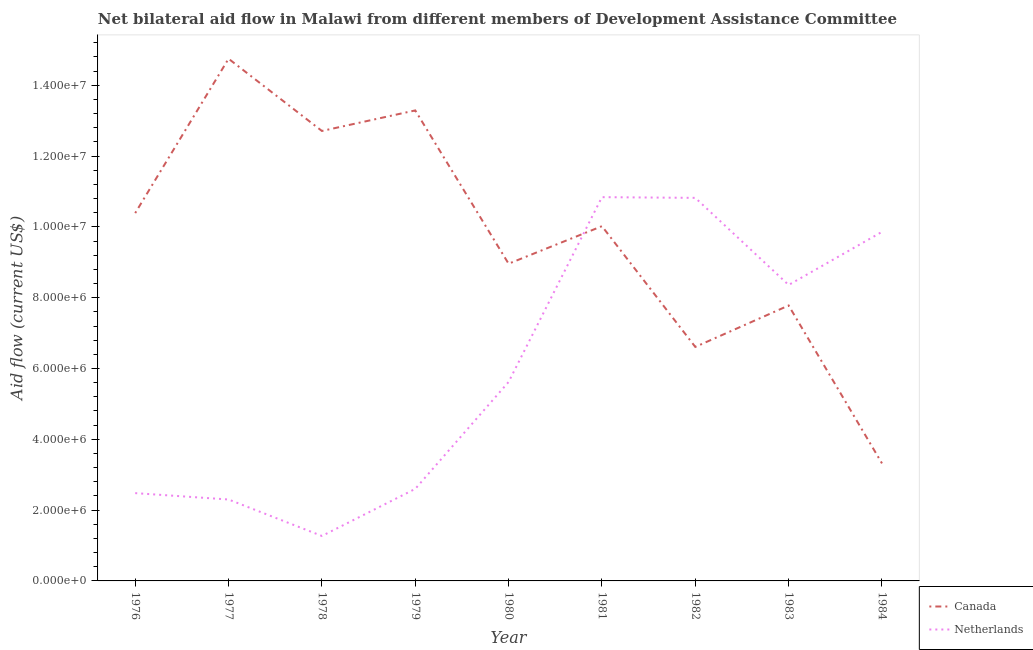How many different coloured lines are there?
Your response must be concise. 2. Does the line corresponding to amount of aid given by canada intersect with the line corresponding to amount of aid given by netherlands?
Provide a short and direct response. Yes. What is the amount of aid given by canada in 1981?
Offer a very short reply. 1.00e+07. Across all years, what is the maximum amount of aid given by netherlands?
Provide a succinct answer. 1.08e+07. Across all years, what is the minimum amount of aid given by canada?
Give a very brief answer. 3.32e+06. In which year was the amount of aid given by canada maximum?
Make the answer very short. 1977. In which year was the amount of aid given by canada minimum?
Your answer should be very brief. 1984. What is the total amount of aid given by canada in the graph?
Keep it short and to the point. 8.78e+07. What is the difference between the amount of aid given by canada in 1977 and that in 1978?
Make the answer very short. 2.04e+06. What is the difference between the amount of aid given by canada in 1977 and the amount of aid given by netherlands in 1982?
Your answer should be compact. 3.93e+06. What is the average amount of aid given by netherlands per year?
Make the answer very short. 6.02e+06. In the year 1976, what is the difference between the amount of aid given by netherlands and amount of aid given by canada?
Provide a succinct answer. -7.91e+06. In how many years, is the amount of aid given by netherlands greater than 6800000 US$?
Provide a short and direct response. 4. What is the ratio of the amount of aid given by netherlands in 1977 to that in 1979?
Your response must be concise. 0.88. Is the amount of aid given by canada in 1977 less than that in 1982?
Ensure brevity in your answer.  No. Is the difference between the amount of aid given by netherlands in 1976 and 1981 greater than the difference between the amount of aid given by canada in 1976 and 1981?
Keep it short and to the point. No. What is the difference between the highest and the second highest amount of aid given by canada?
Your answer should be very brief. 1.46e+06. What is the difference between the highest and the lowest amount of aid given by canada?
Provide a succinct answer. 1.14e+07. Is the amount of aid given by netherlands strictly greater than the amount of aid given by canada over the years?
Your answer should be very brief. No. Is the amount of aid given by netherlands strictly less than the amount of aid given by canada over the years?
Your response must be concise. No. What is the difference between two consecutive major ticks on the Y-axis?
Your response must be concise. 2.00e+06. Are the values on the major ticks of Y-axis written in scientific E-notation?
Ensure brevity in your answer.  Yes. Does the graph contain grids?
Make the answer very short. No. How many legend labels are there?
Ensure brevity in your answer.  2. How are the legend labels stacked?
Your answer should be compact. Vertical. What is the title of the graph?
Offer a very short reply. Net bilateral aid flow in Malawi from different members of Development Assistance Committee. What is the Aid flow (current US$) in Canada in 1976?
Provide a succinct answer. 1.04e+07. What is the Aid flow (current US$) of Netherlands in 1976?
Your answer should be compact. 2.48e+06. What is the Aid flow (current US$) in Canada in 1977?
Ensure brevity in your answer.  1.48e+07. What is the Aid flow (current US$) in Netherlands in 1977?
Offer a terse response. 2.30e+06. What is the Aid flow (current US$) in Canada in 1978?
Offer a terse response. 1.27e+07. What is the Aid flow (current US$) in Netherlands in 1978?
Your answer should be very brief. 1.27e+06. What is the Aid flow (current US$) in Canada in 1979?
Provide a succinct answer. 1.33e+07. What is the Aid flow (current US$) in Netherlands in 1979?
Your answer should be very brief. 2.60e+06. What is the Aid flow (current US$) in Canada in 1980?
Your response must be concise. 8.96e+06. What is the Aid flow (current US$) in Netherlands in 1980?
Ensure brevity in your answer.  5.62e+06. What is the Aid flow (current US$) in Canada in 1981?
Give a very brief answer. 1.00e+07. What is the Aid flow (current US$) in Netherlands in 1981?
Your response must be concise. 1.08e+07. What is the Aid flow (current US$) in Canada in 1982?
Give a very brief answer. 6.61e+06. What is the Aid flow (current US$) in Netherlands in 1982?
Offer a terse response. 1.08e+07. What is the Aid flow (current US$) in Canada in 1983?
Ensure brevity in your answer.  7.78e+06. What is the Aid flow (current US$) in Netherlands in 1983?
Keep it short and to the point. 8.36e+06. What is the Aid flow (current US$) in Canada in 1984?
Offer a very short reply. 3.32e+06. What is the Aid flow (current US$) in Netherlands in 1984?
Keep it short and to the point. 9.86e+06. Across all years, what is the maximum Aid flow (current US$) in Canada?
Your response must be concise. 1.48e+07. Across all years, what is the maximum Aid flow (current US$) of Netherlands?
Offer a very short reply. 1.08e+07. Across all years, what is the minimum Aid flow (current US$) of Canada?
Your answer should be compact. 3.32e+06. Across all years, what is the minimum Aid flow (current US$) in Netherlands?
Make the answer very short. 1.27e+06. What is the total Aid flow (current US$) of Canada in the graph?
Provide a short and direct response. 8.78e+07. What is the total Aid flow (current US$) of Netherlands in the graph?
Provide a succinct answer. 5.42e+07. What is the difference between the Aid flow (current US$) of Canada in 1976 and that in 1977?
Make the answer very short. -4.36e+06. What is the difference between the Aid flow (current US$) of Canada in 1976 and that in 1978?
Your answer should be compact. -2.32e+06. What is the difference between the Aid flow (current US$) in Netherlands in 1976 and that in 1978?
Your response must be concise. 1.21e+06. What is the difference between the Aid flow (current US$) in Canada in 1976 and that in 1979?
Keep it short and to the point. -2.90e+06. What is the difference between the Aid flow (current US$) in Netherlands in 1976 and that in 1979?
Your answer should be very brief. -1.20e+05. What is the difference between the Aid flow (current US$) of Canada in 1976 and that in 1980?
Keep it short and to the point. 1.43e+06. What is the difference between the Aid flow (current US$) in Netherlands in 1976 and that in 1980?
Give a very brief answer. -3.14e+06. What is the difference between the Aid flow (current US$) in Canada in 1976 and that in 1981?
Give a very brief answer. 3.70e+05. What is the difference between the Aid flow (current US$) in Netherlands in 1976 and that in 1981?
Provide a short and direct response. -8.36e+06. What is the difference between the Aid flow (current US$) of Canada in 1976 and that in 1982?
Ensure brevity in your answer.  3.78e+06. What is the difference between the Aid flow (current US$) in Netherlands in 1976 and that in 1982?
Your response must be concise. -8.34e+06. What is the difference between the Aid flow (current US$) in Canada in 1976 and that in 1983?
Offer a very short reply. 2.61e+06. What is the difference between the Aid flow (current US$) of Netherlands in 1976 and that in 1983?
Your response must be concise. -5.88e+06. What is the difference between the Aid flow (current US$) of Canada in 1976 and that in 1984?
Your answer should be very brief. 7.07e+06. What is the difference between the Aid flow (current US$) in Netherlands in 1976 and that in 1984?
Keep it short and to the point. -7.38e+06. What is the difference between the Aid flow (current US$) in Canada in 1977 and that in 1978?
Ensure brevity in your answer.  2.04e+06. What is the difference between the Aid flow (current US$) of Netherlands in 1977 and that in 1978?
Provide a short and direct response. 1.03e+06. What is the difference between the Aid flow (current US$) of Canada in 1977 and that in 1979?
Ensure brevity in your answer.  1.46e+06. What is the difference between the Aid flow (current US$) of Netherlands in 1977 and that in 1979?
Give a very brief answer. -3.00e+05. What is the difference between the Aid flow (current US$) in Canada in 1977 and that in 1980?
Make the answer very short. 5.79e+06. What is the difference between the Aid flow (current US$) in Netherlands in 1977 and that in 1980?
Provide a succinct answer. -3.32e+06. What is the difference between the Aid flow (current US$) in Canada in 1977 and that in 1981?
Give a very brief answer. 4.73e+06. What is the difference between the Aid flow (current US$) of Netherlands in 1977 and that in 1981?
Give a very brief answer. -8.54e+06. What is the difference between the Aid flow (current US$) of Canada in 1977 and that in 1982?
Your answer should be very brief. 8.14e+06. What is the difference between the Aid flow (current US$) in Netherlands in 1977 and that in 1982?
Keep it short and to the point. -8.52e+06. What is the difference between the Aid flow (current US$) in Canada in 1977 and that in 1983?
Provide a succinct answer. 6.97e+06. What is the difference between the Aid flow (current US$) of Netherlands in 1977 and that in 1983?
Your answer should be compact. -6.06e+06. What is the difference between the Aid flow (current US$) of Canada in 1977 and that in 1984?
Ensure brevity in your answer.  1.14e+07. What is the difference between the Aid flow (current US$) in Netherlands in 1977 and that in 1984?
Make the answer very short. -7.56e+06. What is the difference between the Aid flow (current US$) in Canada in 1978 and that in 1979?
Offer a terse response. -5.80e+05. What is the difference between the Aid flow (current US$) of Netherlands in 1978 and that in 1979?
Provide a succinct answer. -1.33e+06. What is the difference between the Aid flow (current US$) of Canada in 1978 and that in 1980?
Offer a terse response. 3.75e+06. What is the difference between the Aid flow (current US$) of Netherlands in 1978 and that in 1980?
Your answer should be very brief. -4.35e+06. What is the difference between the Aid flow (current US$) of Canada in 1978 and that in 1981?
Your answer should be very brief. 2.69e+06. What is the difference between the Aid flow (current US$) of Netherlands in 1978 and that in 1981?
Your response must be concise. -9.57e+06. What is the difference between the Aid flow (current US$) in Canada in 1978 and that in 1982?
Ensure brevity in your answer.  6.10e+06. What is the difference between the Aid flow (current US$) of Netherlands in 1978 and that in 1982?
Keep it short and to the point. -9.55e+06. What is the difference between the Aid flow (current US$) of Canada in 1978 and that in 1983?
Give a very brief answer. 4.93e+06. What is the difference between the Aid flow (current US$) in Netherlands in 1978 and that in 1983?
Provide a succinct answer. -7.09e+06. What is the difference between the Aid flow (current US$) of Canada in 1978 and that in 1984?
Your answer should be compact. 9.39e+06. What is the difference between the Aid flow (current US$) in Netherlands in 1978 and that in 1984?
Your response must be concise. -8.59e+06. What is the difference between the Aid flow (current US$) in Canada in 1979 and that in 1980?
Ensure brevity in your answer.  4.33e+06. What is the difference between the Aid flow (current US$) in Netherlands in 1979 and that in 1980?
Provide a succinct answer. -3.02e+06. What is the difference between the Aid flow (current US$) in Canada in 1979 and that in 1981?
Your answer should be very brief. 3.27e+06. What is the difference between the Aid flow (current US$) of Netherlands in 1979 and that in 1981?
Provide a short and direct response. -8.24e+06. What is the difference between the Aid flow (current US$) in Canada in 1979 and that in 1982?
Make the answer very short. 6.68e+06. What is the difference between the Aid flow (current US$) in Netherlands in 1979 and that in 1982?
Make the answer very short. -8.22e+06. What is the difference between the Aid flow (current US$) in Canada in 1979 and that in 1983?
Offer a very short reply. 5.51e+06. What is the difference between the Aid flow (current US$) of Netherlands in 1979 and that in 1983?
Offer a very short reply. -5.76e+06. What is the difference between the Aid flow (current US$) in Canada in 1979 and that in 1984?
Offer a terse response. 9.97e+06. What is the difference between the Aid flow (current US$) of Netherlands in 1979 and that in 1984?
Provide a succinct answer. -7.26e+06. What is the difference between the Aid flow (current US$) in Canada in 1980 and that in 1981?
Keep it short and to the point. -1.06e+06. What is the difference between the Aid flow (current US$) of Netherlands in 1980 and that in 1981?
Keep it short and to the point. -5.22e+06. What is the difference between the Aid flow (current US$) of Canada in 1980 and that in 1982?
Your answer should be compact. 2.35e+06. What is the difference between the Aid flow (current US$) in Netherlands in 1980 and that in 1982?
Your answer should be compact. -5.20e+06. What is the difference between the Aid flow (current US$) of Canada in 1980 and that in 1983?
Make the answer very short. 1.18e+06. What is the difference between the Aid flow (current US$) in Netherlands in 1980 and that in 1983?
Your response must be concise. -2.74e+06. What is the difference between the Aid flow (current US$) in Canada in 1980 and that in 1984?
Make the answer very short. 5.64e+06. What is the difference between the Aid flow (current US$) in Netherlands in 1980 and that in 1984?
Give a very brief answer. -4.24e+06. What is the difference between the Aid flow (current US$) of Canada in 1981 and that in 1982?
Ensure brevity in your answer.  3.41e+06. What is the difference between the Aid flow (current US$) of Canada in 1981 and that in 1983?
Provide a succinct answer. 2.24e+06. What is the difference between the Aid flow (current US$) of Netherlands in 1981 and that in 1983?
Give a very brief answer. 2.48e+06. What is the difference between the Aid flow (current US$) in Canada in 1981 and that in 1984?
Keep it short and to the point. 6.70e+06. What is the difference between the Aid flow (current US$) in Netherlands in 1981 and that in 1984?
Give a very brief answer. 9.80e+05. What is the difference between the Aid flow (current US$) of Canada in 1982 and that in 1983?
Your answer should be compact. -1.17e+06. What is the difference between the Aid flow (current US$) of Netherlands in 1982 and that in 1983?
Give a very brief answer. 2.46e+06. What is the difference between the Aid flow (current US$) of Canada in 1982 and that in 1984?
Give a very brief answer. 3.29e+06. What is the difference between the Aid flow (current US$) in Netherlands in 1982 and that in 1984?
Provide a short and direct response. 9.60e+05. What is the difference between the Aid flow (current US$) in Canada in 1983 and that in 1984?
Your answer should be very brief. 4.46e+06. What is the difference between the Aid flow (current US$) of Netherlands in 1983 and that in 1984?
Provide a succinct answer. -1.50e+06. What is the difference between the Aid flow (current US$) of Canada in 1976 and the Aid flow (current US$) of Netherlands in 1977?
Offer a very short reply. 8.09e+06. What is the difference between the Aid flow (current US$) of Canada in 1976 and the Aid flow (current US$) of Netherlands in 1978?
Offer a very short reply. 9.12e+06. What is the difference between the Aid flow (current US$) of Canada in 1976 and the Aid flow (current US$) of Netherlands in 1979?
Provide a succinct answer. 7.79e+06. What is the difference between the Aid flow (current US$) of Canada in 1976 and the Aid flow (current US$) of Netherlands in 1980?
Your response must be concise. 4.77e+06. What is the difference between the Aid flow (current US$) in Canada in 1976 and the Aid flow (current US$) in Netherlands in 1981?
Offer a terse response. -4.50e+05. What is the difference between the Aid flow (current US$) of Canada in 1976 and the Aid flow (current US$) of Netherlands in 1982?
Ensure brevity in your answer.  -4.30e+05. What is the difference between the Aid flow (current US$) in Canada in 1976 and the Aid flow (current US$) in Netherlands in 1983?
Provide a succinct answer. 2.03e+06. What is the difference between the Aid flow (current US$) in Canada in 1976 and the Aid flow (current US$) in Netherlands in 1984?
Provide a succinct answer. 5.30e+05. What is the difference between the Aid flow (current US$) of Canada in 1977 and the Aid flow (current US$) of Netherlands in 1978?
Offer a terse response. 1.35e+07. What is the difference between the Aid flow (current US$) of Canada in 1977 and the Aid flow (current US$) of Netherlands in 1979?
Keep it short and to the point. 1.22e+07. What is the difference between the Aid flow (current US$) of Canada in 1977 and the Aid flow (current US$) of Netherlands in 1980?
Your answer should be compact. 9.13e+06. What is the difference between the Aid flow (current US$) in Canada in 1977 and the Aid flow (current US$) in Netherlands in 1981?
Your response must be concise. 3.91e+06. What is the difference between the Aid flow (current US$) in Canada in 1977 and the Aid flow (current US$) in Netherlands in 1982?
Offer a terse response. 3.93e+06. What is the difference between the Aid flow (current US$) of Canada in 1977 and the Aid flow (current US$) of Netherlands in 1983?
Keep it short and to the point. 6.39e+06. What is the difference between the Aid flow (current US$) of Canada in 1977 and the Aid flow (current US$) of Netherlands in 1984?
Keep it short and to the point. 4.89e+06. What is the difference between the Aid flow (current US$) in Canada in 1978 and the Aid flow (current US$) in Netherlands in 1979?
Provide a short and direct response. 1.01e+07. What is the difference between the Aid flow (current US$) in Canada in 1978 and the Aid flow (current US$) in Netherlands in 1980?
Ensure brevity in your answer.  7.09e+06. What is the difference between the Aid flow (current US$) in Canada in 1978 and the Aid flow (current US$) in Netherlands in 1981?
Give a very brief answer. 1.87e+06. What is the difference between the Aid flow (current US$) in Canada in 1978 and the Aid flow (current US$) in Netherlands in 1982?
Your response must be concise. 1.89e+06. What is the difference between the Aid flow (current US$) of Canada in 1978 and the Aid flow (current US$) of Netherlands in 1983?
Your answer should be very brief. 4.35e+06. What is the difference between the Aid flow (current US$) of Canada in 1978 and the Aid flow (current US$) of Netherlands in 1984?
Make the answer very short. 2.85e+06. What is the difference between the Aid flow (current US$) in Canada in 1979 and the Aid flow (current US$) in Netherlands in 1980?
Your answer should be compact. 7.67e+06. What is the difference between the Aid flow (current US$) of Canada in 1979 and the Aid flow (current US$) of Netherlands in 1981?
Make the answer very short. 2.45e+06. What is the difference between the Aid flow (current US$) of Canada in 1979 and the Aid flow (current US$) of Netherlands in 1982?
Ensure brevity in your answer.  2.47e+06. What is the difference between the Aid flow (current US$) of Canada in 1979 and the Aid flow (current US$) of Netherlands in 1983?
Provide a succinct answer. 4.93e+06. What is the difference between the Aid flow (current US$) of Canada in 1979 and the Aid flow (current US$) of Netherlands in 1984?
Offer a very short reply. 3.43e+06. What is the difference between the Aid flow (current US$) of Canada in 1980 and the Aid flow (current US$) of Netherlands in 1981?
Make the answer very short. -1.88e+06. What is the difference between the Aid flow (current US$) in Canada in 1980 and the Aid flow (current US$) in Netherlands in 1982?
Provide a short and direct response. -1.86e+06. What is the difference between the Aid flow (current US$) of Canada in 1980 and the Aid flow (current US$) of Netherlands in 1983?
Keep it short and to the point. 6.00e+05. What is the difference between the Aid flow (current US$) in Canada in 1980 and the Aid flow (current US$) in Netherlands in 1984?
Offer a terse response. -9.00e+05. What is the difference between the Aid flow (current US$) in Canada in 1981 and the Aid flow (current US$) in Netherlands in 1982?
Offer a very short reply. -8.00e+05. What is the difference between the Aid flow (current US$) of Canada in 1981 and the Aid flow (current US$) of Netherlands in 1983?
Give a very brief answer. 1.66e+06. What is the difference between the Aid flow (current US$) of Canada in 1981 and the Aid flow (current US$) of Netherlands in 1984?
Offer a terse response. 1.60e+05. What is the difference between the Aid flow (current US$) of Canada in 1982 and the Aid flow (current US$) of Netherlands in 1983?
Make the answer very short. -1.75e+06. What is the difference between the Aid flow (current US$) in Canada in 1982 and the Aid flow (current US$) in Netherlands in 1984?
Give a very brief answer. -3.25e+06. What is the difference between the Aid flow (current US$) in Canada in 1983 and the Aid flow (current US$) in Netherlands in 1984?
Provide a succinct answer. -2.08e+06. What is the average Aid flow (current US$) of Canada per year?
Your answer should be compact. 9.76e+06. What is the average Aid flow (current US$) of Netherlands per year?
Make the answer very short. 6.02e+06. In the year 1976, what is the difference between the Aid flow (current US$) in Canada and Aid flow (current US$) in Netherlands?
Keep it short and to the point. 7.91e+06. In the year 1977, what is the difference between the Aid flow (current US$) in Canada and Aid flow (current US$) in Netherlands?
Your answer should be compact. 1.24e+07. In the year 1978, what is the difference between the Aid flow (current US$) in Canada and Aid flow (current US$) in Netherlands?
Your answer should be very brief. 1.14e+07. In the year 1979, what is the difference between the Aid flow (current US$) in Canada and Aid flow (current US$) in Netherlands?
Provide a succinct answer. 1.07e+07. In the year 1980, what is the difference between the Aid flow (current US$) of Canada and Aid flow (current US$) of Netherlands?
Provide a succinct answer. 3.34e+06. In the year 1981, what is the difference between the Aid flow (current US$) of Canada and Aid flow (current US$) of Netherlands?
Give a very brief answer. -8.20e+05. In the year 1982, what is the difference between the Aid flow (current US$) of Canada and Aid flow (current US$) of Netherlands?
Offer a very short reply. -4.21e+06. In the year 1983, what is the difference between the Aid flow (current US$) of Canada and Aid flow (current US$) of Netherlands?
Give a very brief answer. -5.80e+05. In the year 1984, what is the difference between the Aid flow (current US$) of Canada and Aid flow (current US$) of Netherlands?
Offer a terse response. -6.54e+06. What is the ratio of the Aid flow (current US$) of Canada in 1976 to that in 1977?
Provide a succinct answer. 0.7. What is the ratio of the Aid flow (current US$) of Netherlands in 1976 to that in 1977?
Make the answer very short. 1.08. What is the ratio of the Aid flow (current US$) in Canada in 1976 to that in 1978?
Make the answer very short. 0.82. What is the ratio of the Aid flow (current US$) in Netherlands in 1976 to that in 1978?
Offer a terse response. 1.95. What is the ratio of the Aid flow (current US$) of Canada in 1976 to that in 1979?
Your response must be concise. 0.78. What is the ratio of the Aid flow (current US$) in Netherlands in 1976 to that in 1979?
Make the answer very short. 0.95. What is the ratio of the Aid flow (current US$) in Canada in 1976 to that in 1980?
Your answer should be very brief. 1.16. What is the ratio of the Aid flow (current US$) in Netherlands in 1976 to that in 1980?
Make the answer very short. 0.44. What is the ratio of the Aid flow (current US$) of Canada in 1976 to that in 1981?
Your response must be concise. 1.04. What is the ratio of the Aid flow (current US$) in Netherlands in 1976 to that in 1981?
Offer a terse response. 0.23. What is the ratio of the Aid flow (current US$) in Canada in 1976 to that in 1982?
Provide a short and direct response. 1.57. What is the ratio of the Aid flow (current US$) in Netherlands in 1976 to that in 1982?
Ensure brevity in your answer.  0.23. What is the ratio of the Aid flow (current US$) in Canada in 1976 to that in 1983?
Make the answer very short. 1.34. What is the ratio of the Aid flow (current US$) in Netherlands in 1976 to that in 1983?
Keep it short and to the point. 0.3. What is the ratio of the Aid flow (current US$) in Canada in 1976 to that in 1984?
Your answer should be very brief. 3.13. What is the ratio of the Aid flow (current US$) of Netherlands in 1976 to that in 1984?
Your answer should be very brief. 0.25. What is the ratio of the Aid flow (current US$) of Canada in 1977 to that in 1978?
Your answer should be very brief. 1.16. What is the ratio of the Aid flow (current US$) in Netherlands in 1977 to that in 1978?
Keep it short and to the point. 1.81. What is the ratio of the Aid flow (current US$) in Canada in 1977 to that in 1979?
Make the answer very short. 1.11. What is the ratio of the Aid flow (current US$) of Netherlands in 1977 to that in 1979?
Your answer should be compact. 0.88. What is the ratio of the Aid flow (current US$) of Canada in 1977 to that in 1980?
Give a very brief answer. 1.65. What is the ratio of the Aid flow (current US$) in Netherlands in 1977 to that in 1980?
Make the answer very short. 0.41. What is the ratio of the Aid flow (current US$) of Canada in 1977 to that in 1981?
Offer a terse response. 1.47. What is the ratio of the Aid flow (current US$) of Netherlands in 1977 to that in 1981?
Provide a succinct answer. 0.21. What is the ratio of the Aid flow (current US$) of Canada in 1977 to that in 1982?
Provide a short and direct response. 2.23. What is the ratio of the Aid flow (current US$) of Netherlands in 1977 to that in 1982?
Offer a terse response. 0.21. What is the ratio of the Aid flow (current US$) in Canada in 1977 to that in 1983?
Your response must be concise. 1.9. What is the ratio of the Aid flow (current US$) of Netherlands in 1977 to that in 1983?
Offer a very short reply. 0.28. What is the ratio of the Aid flow (current US$) of Canada in 1977 to that in 1984?
Give a very brief answer. 4.44. What is the ratio of the Aid flow (current US$) of Netherlands in 1977 to that in 1984?
Offer a terse response. 0.23. What is the ratio of the Aid flow (current US$) of Canada in 1978 to that in 1979?
Your answer should be compact. 0.96. What is the ratio of the Aid flow (current US$) of Netherlands in 1978 to that in 1979?
Offer a very short reply. 0.49. What is the ratio of the Aid flow (current US$) in Canada in 1978 to that in 1980?
Make the answer very short. 1.42. What is the ratio of the Aid flow (current US$) of Netherlands in 1978 to that in 1980?
Offer a terse response. 0.23. What is the ratio of the Aid flow (current US$) in Canada in 1978 to that in 1981?
Your response must be concise. 1.27. What is the ratio of the Aid flow (current US$) of Netherlands in 1978 to that in 1981?
Your answer should be very brief. 0.12. What is the ratio of the Aid flow (current US$) in Canada in 1978 to that in 1982?
Your answer should be compact. 1.92. What is the ratio of the Aid flow (current US$) in Netherlands in 1978 to that in 1982?
Ensure brevity in your answer.  0.12. What is the ratio of the Aid flow (current US$) of Canada in 1978 to that in 1983?
Offer a terse response. 1.63. What is the ratio of the Aid flow (current US$) of Netherlands in 1978 to that in 1983?
Provide a short and direct response. 0.15. What is the ratio of the Aid flow (current US$) in Canada in 1978 to that in 1984?
Keep it short and to the point. 3.83. What is the ratio of the Aid flow (current US$) in Netherlands in 1978 to that in 1984?
Provide a succinct answer. 0.13. What is the ratio of the Aid flow (current US$) of Canada in 1979 to that in 1980?
Your answer should be compact. 1.48. What is the ratio of the Aid flow (current US$) of Netherlands in 1979 to that in 1980?
Ensure brevity in your answer.  0.46. What is the ratio of the Aid flow (current US$) of Canada in 1979 to that in 1981?
Your answer should be very brief. 1.33. What is the ratio of the Aid flow (current US$) of Netherlands in 1979 to that in 1981?
Make the answer very short. 0.24. What is the ratio of the Aid flow (current US$) of Canada in 1979 to that in 1982?
Your answer should be very brief. 2.01. What is the ratio of the Aid flow (current US$) of Netherlands in 1979 to that in 1982?
Offer a very short reply. 0.24. What is the ratio of the Aid flow (current US$) of Canada in 1979 to that in 1983?
Make the answer very short. 1.71. What is the ratio of the Aid flow (current US$) in Netherlands in 1979 to that in 1983?
Offer a terse response. 0.31. What is the ratio of the Aid flow (current US$) of Canada in 1979 to that in 1984?
Your answer should be very brief. 4. What is the ratio of the Aid flow (current US$) of Netherlands in 1979 to that in 1984?
Provide a short and direct response. 0.26. What is the ratio of the Aid flow (current US$) in Canada in 1980 to that in 1981?
Provide a short and direct response. 0.89. What is the ratio of the Aid flow (current US$) in Netherlands in 1980 to that in 1981?
Give a very brief answer. 0.52. What is the ratio of the Aid flow (current US$) in Canada in 1980 to that in 1982?
Make the answer very short. 1.36. What is the ratio of the Aid flow (current US$) in Netherlands in 1980 to that in 1982?
Your response must be concise. 0.52. What is the ratio of the Aid flow (current US$) in Canada in 1980 to that in 1983?
Make the answer very short. 1.15. What is the ratio of the Aid flow (current US$) of Netherlands in 1980 to that in 1983?
Offer a terse response. 0.67. What is the ratio of the Aid flow (current US$) in Canada in 1980 to that in 1984?
Keep it short and to the point. 2.7. What is the ratio of the Aid flow (current US$) in Netherlands in 1980 to that in 1984?
Ensure brevity in your answer.  0.57. What is the ratio of the Aid flow (current US$) of Canada in 1981 to that in 1982?
Your response must be concise. 1.52. What is the ratio of the Aid flow (current US$) in Canada in 1981 to that in 1983?
Provide a short and direct response. 1.29. What is the ratio of the Aid flow (current US$) in Netherlands in 1981 to that in 1983?
Give a very brief answer. 1.3. What is the ratio of the Aid flow (current US$) of Canada in 1981 to that in 1984?
Keep it short and to the point. 3.02. What is the ratio of the Aid flow (current US$) in Netherlands in 1981 to that in 1984?
Your answer should be very brief. 1.1. What is the ratio of the Aid flow (current US$) in Canada in 1982 to that in 1983?
Make the answer very short. 0.85. What is the ratio of the Aid flow (current US$) in Netherlands in 1982 to that in 1983?
Offer a very short reply. 1.29. What is the ratio of the Aid flow (current US$) in Canada in 1982 to that in 1984?
Your answer should be very brief. 1.99. What is the ratio of the Aid flow (current US$) of Netherlands in 1982 to that in 1984?
Give a very brief answer. 1.1. What is the ratio of the Aid flow (current US$) of Canada in 1983 to that in 1984?
Keep it short and to the point. 2.34. What is the ratio of the Aid flow (current US$) in Netherlands in 1983 to that in 1984?
Ensure brevity in your answer.  0.85. What is the difference between the highest and the second highest Aid flow (current US$) of Canada?
Give a very brief answer. 1.46e+06. What is the difference between the highest and the lowest Aid flow (current US$) of Canada?
Offer a very short reply. 1.14e+07. What is the difference between the highest and the lowest Aid flow (current US$) of Netherlands?
Your answer should be compact. 9.57e+06. 